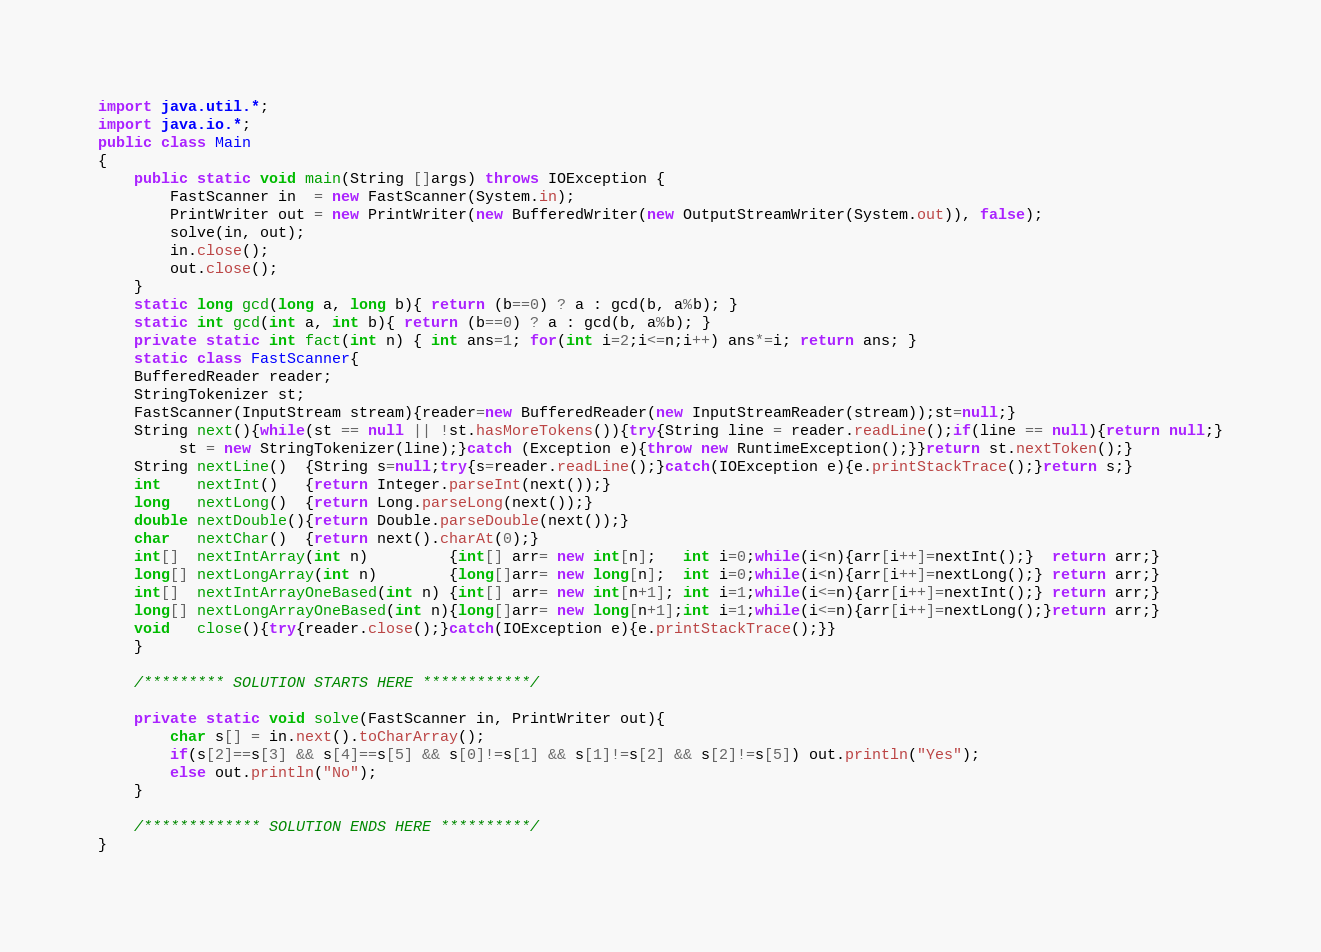<code> <loc_0><loc_0><loc_500><loc_500><_Java_>import java.util.*;
import java.io.*;
public class Main
{
    public static void main(String []args) throws IOException {
    	FastScanner in  = new FastScanner(System.in);
    	PrintWriter out = new PrintWriter(new BufferedWriter(new OutputStreamWriter(System.out)), false);
    	solve(in, out);
    	in.close();
    	out.close();
    }
    static long gcd(long a, long b){ return (b==0) ? a : gcd(b, a%b); }
    static int gcd(int a, int b){ return (b==0) ? a : gcd(b, a%b); }
    private static int fact(int n) { int ans=1; for(int i=2;i<=n;i++) ans*=i; return ans; }
    static class FastScanner{
	BufferedReader reader;
	StringTokenizer st;
	FastScanner(InputStream stream){reader=new BufferedReader(new InputStreamReader(stream));st=null;}
	String next(){while(st == null || !st.hasMoreTokens()){try{String line = reader.readLine();if(line == null){return null;}
	     st = new StringTokenizer(line);}catch (Exception e){throw new RuntimeException();}}return st.nextToken();}
	String nextLine()  {String s=null;try{s=reader.readLine();}catch(IOException e){e.printStackTrace();}return s;}
	int    nextInt()   {return Integer.parseInt(next());}
	long   nextLong()  {return Long.parseLong(next());}
	double nextDouble(){return Double.parseDouble(next());}
	char   nextChar()  {return next().charAt(0);}
	int[]  nextIntArray(int n)         {int[] arr= new int[n];   int i=0;while(i<n){arr[i++]=nextInt();}  return arr;}
	long[] nextLongArray(int n)        {long[]arr= new long[n];  int i=0;while(i<n){arr[i++]=nextLong();} return arr;}
	int[]  nextIntArrayOneBased(int n) {int[] arr= new int[n+1]; int i=1;while(i<=n){arr[i++]=nextInt();} return arr;}
	long[] nextLongArrayOneBased(int n){long[]arr= new long[n+1];int i=1;while(i<=n){arr[i++]=nextLong();}return arr;}
	void   close(){try{reader.close();}catch(IOException e){e.printStackTrace();}}
    }
    
    /********* SOLUTION STARTS HERE ************/
    
    private static void solve(FastScanner in, PrintWriter out){
        char s[] = in.next().toCharArray();
        if(s[2]==s[3] && s[4]==s[5] && s[0]!=s[1] && s[1]!=s[2] && s[2]!=s[5]) out.println("Yes");
        else out.println("No");
    }
    
    /************* SOLUTION ENDS HERE **********/
}</code> 